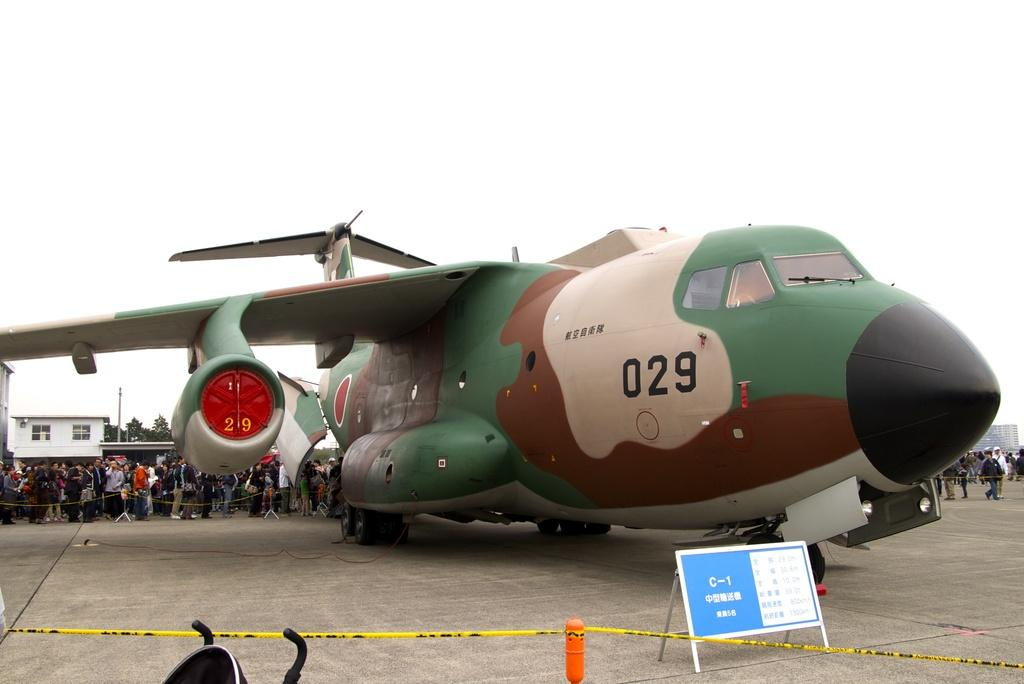Provide a one-sentence caption for the provided image. A multi-colored C-1 airplane, numbered 029, draws a huge crowd. 